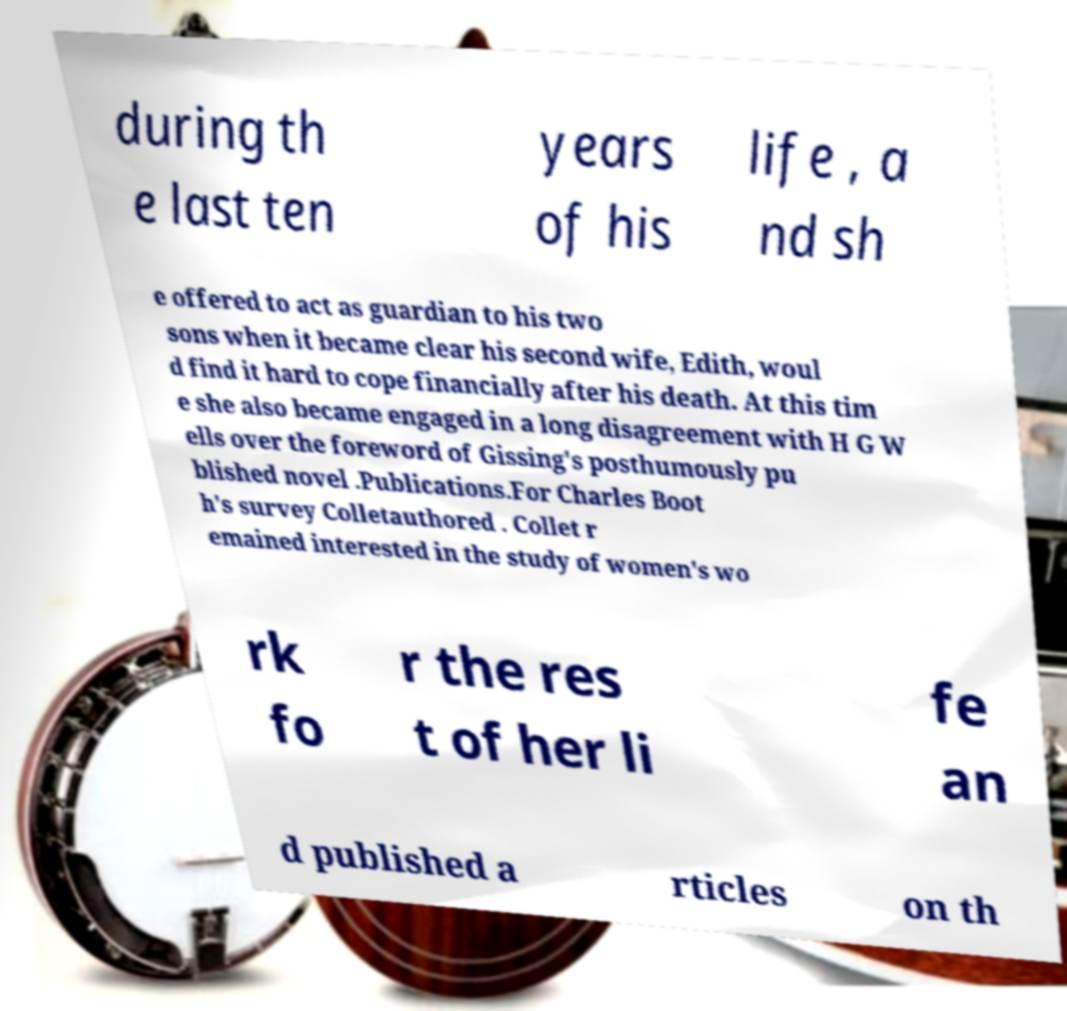What messages or text are displayed in this image? I need them in a readable, typed format. during th e last ten years of his life , a nd sh e offered to act as guardian to his two sons when it became clear his second wife, Edith, woul d find it hard to cope financially after his death. At this tim e she also became engaged in a long disagreement with H G W ells over the foreword of Gissing's posthumously pu blished novel .Publications.For Charles Boot h's survey Colletauthored . Collet r emained interested in the study of women's wo rk fo r the res t of her li fe an d published a rticles on th 